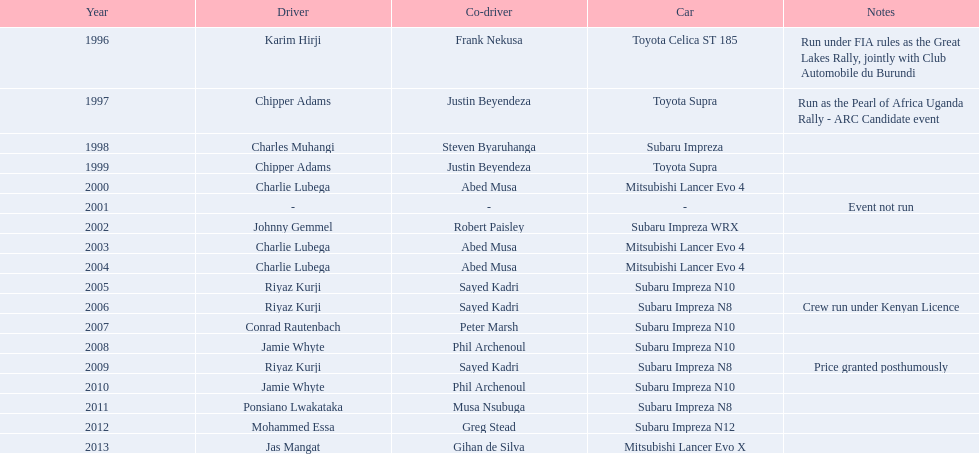How many times did a mitsubishi lancer secure a win prior to the year 2004? 2. 